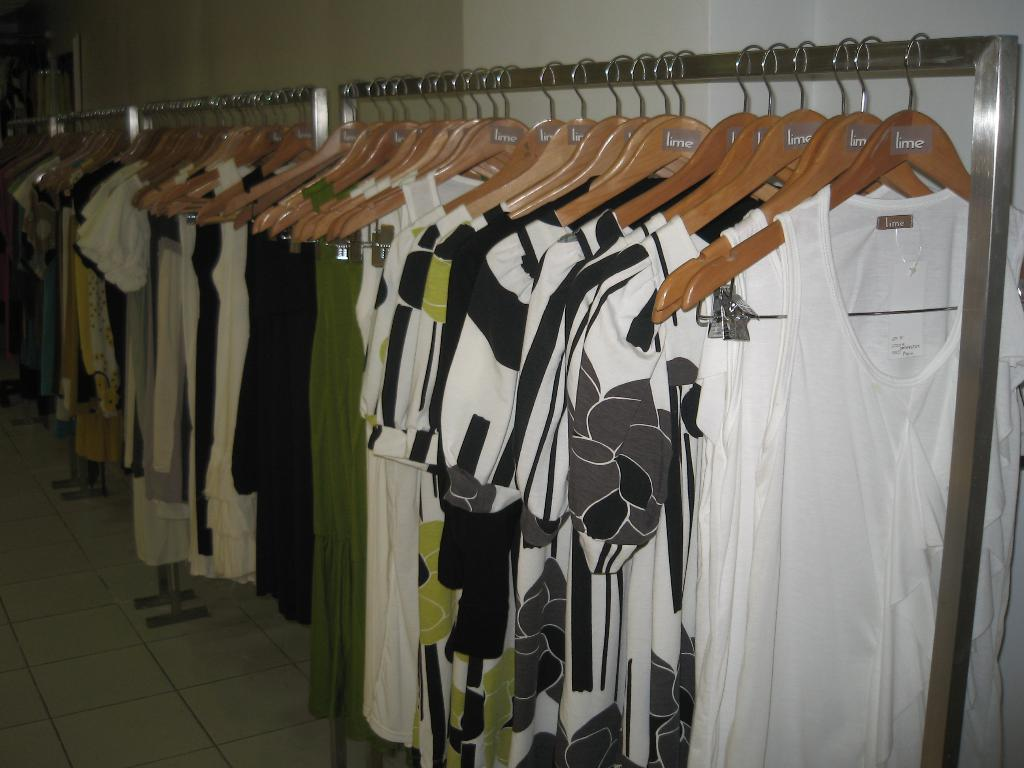What is hanging on the metal rods in the image? There are clothes hanging on metal rods in the image. What can be seen in the background of the image? There is a wall visible in the background of the image. Where is the airplane parked in the image? There is no airplane present in the image. What type of selection is available for the clothes hanging on the metal rods? The image does not provide information about the selection of clothes; it only shows that clothes are hanging on metal rods. --- Facts: 1. There is a person sitting on a bench in the image. 2. The person is reading a book. 3. There is a tree behind the bench. 4. The ground is visible in the image. Absurd Topics: parrot, ocean, bicycle Conversation: What is the person in the image doing? The person is sitting on a bench in the image. What activity is the person engaged in while sitting on the bench? The person is reading a book. What can be seen behind the bench in the image? There is a tree behind the bench. What is visible beneath the bench in the image? The ground is visible in the image. Reasoning: Let's think step by step in order to produce the conversation. We start by identifying the main subject in the image, which is the person sitting on a bench. Then, we expand the conversation to include the activity the person is engaged in (reading a book) and the surrounding environment (tree and ground). Each question is designed to elicit a specific detail about the image that is known from the provided facts. Absurd Question/Answer: What type of parrot is sitting on the person's shoulder in the image? There is no parrot present in the image. Can you see the ocean in the background of the image? The image does not show the ocean; it only shows a tree and the ground. 